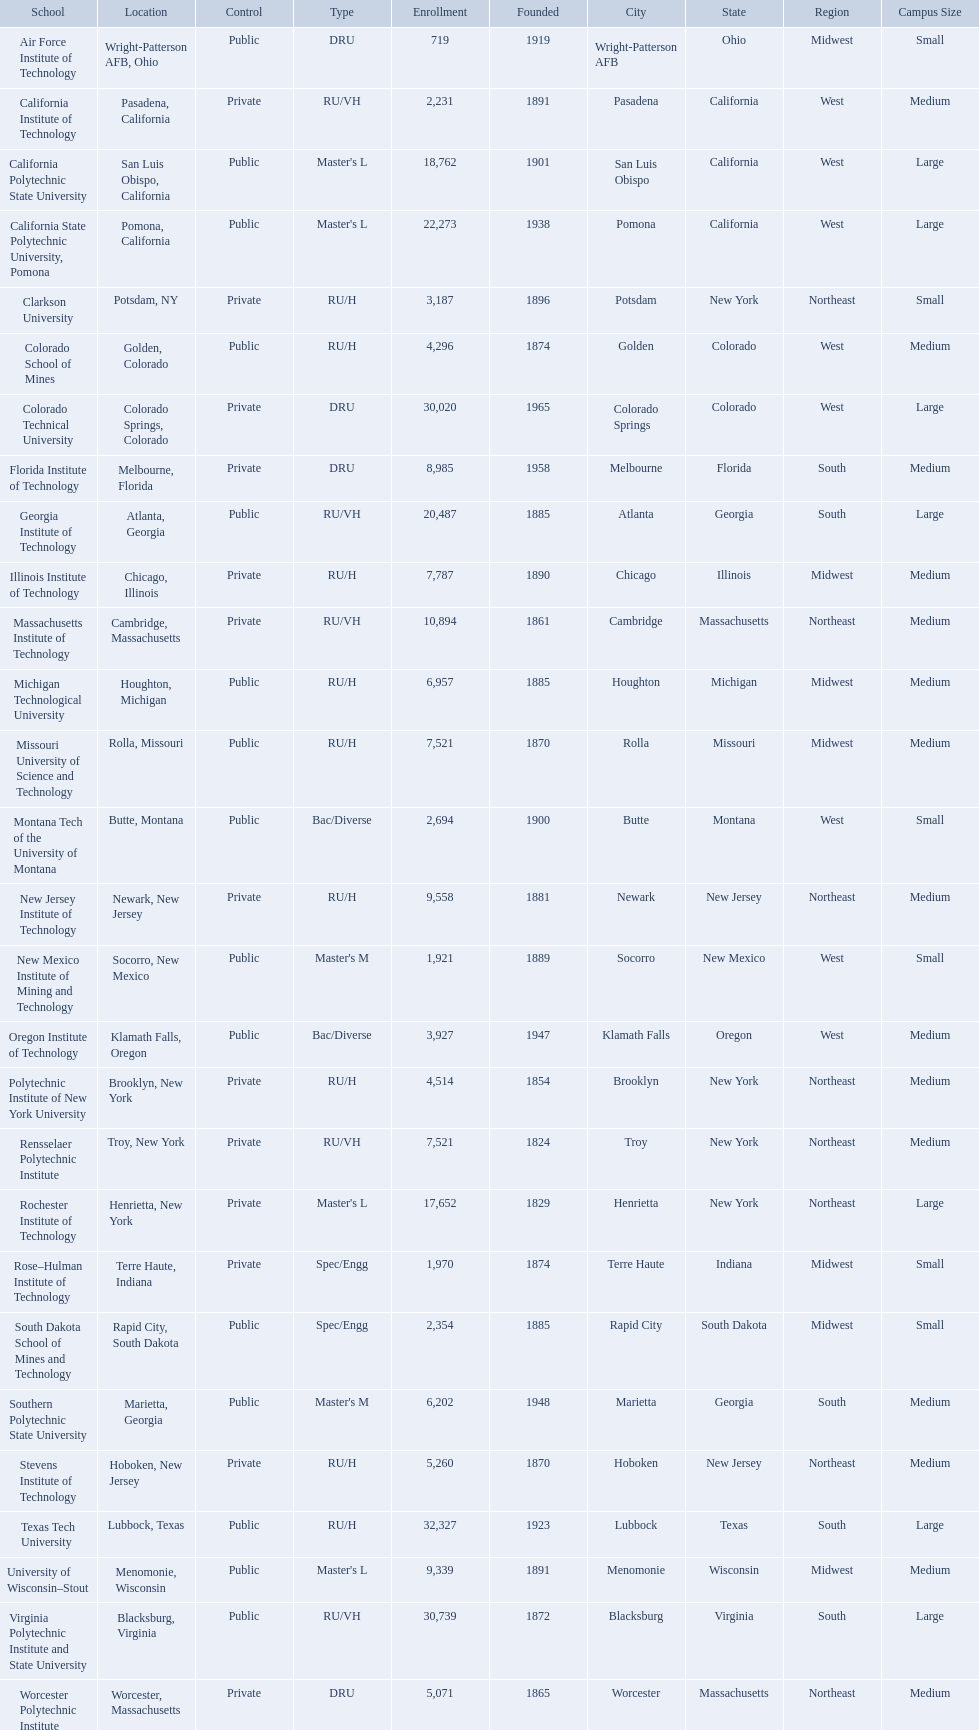What are the listed enrollment numbers of us universities? 719, 2,231, 18,762, 22,273, 3,187, 4,296, 30,020, 8,985, 20,487, 7,787, 10,894, 6,957, 7,521, 2,694, 9,558, 1,921, 3,927, 4,514, 7,521, 17,652, 1,970, 2,354, 6,202, 5,260, 32,327, 9,339, 30,739, 5,071. Of these, which has the highest value? 32,327. What are the listed names of us universities? Air Force Institute of Technology, California Institute of Technology, California Polytechnic State University, California State Polytechnic University, Pomona, Clarkson University, Colorado School of Mines, Colorado Technical University, Florida Institute of Technology, Georgia Institute of Technology, Illinois Institute of Technology, Massachusetts Institute of Technology, Michigan Technological University, Missouri University of Science and Technology, Montana Tech of the University of Montana, New Jersey Institute of Technology, New Mexico Institute of Mining and Technology, Oregon Institute of Technology, Polytechnic Institute of New York University, Rensselaer Polytechnic Institute, Rochester Institute of Technology, Rose–Hulman Institute of Technology, South Dakota School of Mines and Technology, Southern Polytechnic State University, Stevens Institute of Technology, Texas Tech University, University of Wisconsin–Stout, Virginia Polytechnic Institute and State University, Worcester Polytechnic Institute. Which of these correspond to the previously listed highest enrollment value? Texas Tech University. What are all the schools? Air Force Institute of Technology, California Institute of Technology, California Polytechnic State University, California State Polytechnic University, Pomona, Clarkson University, Colorado School of Mines, Colorado Technical University, Florida Institute of Technology, Georgia Institute of Technology, Illinois Institute of Technology, Massachusetts Institute of Technology, Michigan Technological University, Missouri University of Science and Technology, Montana Tech of the University of Montana, New Jersey Institute of Technology, New Mexico Institute of Mining and Technology, Oregon Institute of Technology, Polytechnic Institute of New York University, Rensselaer Polytechnic Institute, Rochester Institute of Technology, Rose–Hulman Institute of Technology, South Dakota School of Mines and Technology, Southern Polytechnic State University, Stevens Institute of Technology, Texas Tech University, University of Wisconsin–Stout, Virginia Polytechnic Institute and State University, Worcester Polytechnic Institute. What is the enrollment of each school? 719, 2,231, 18,762, 22,273, 3,187, 4,296, 30,020, 8,985, 20,487, 7,787, 10,894, 6,957, 7,521, 2,694, 9,558, 1,921, 3,927, 4,514, 7,521, 17,652, 1,970, 2,354, 6,202, 5,260, 32,327, 9,339, 30,739, 5,071. And which school had the highest enrollment? Texas Tech University. 